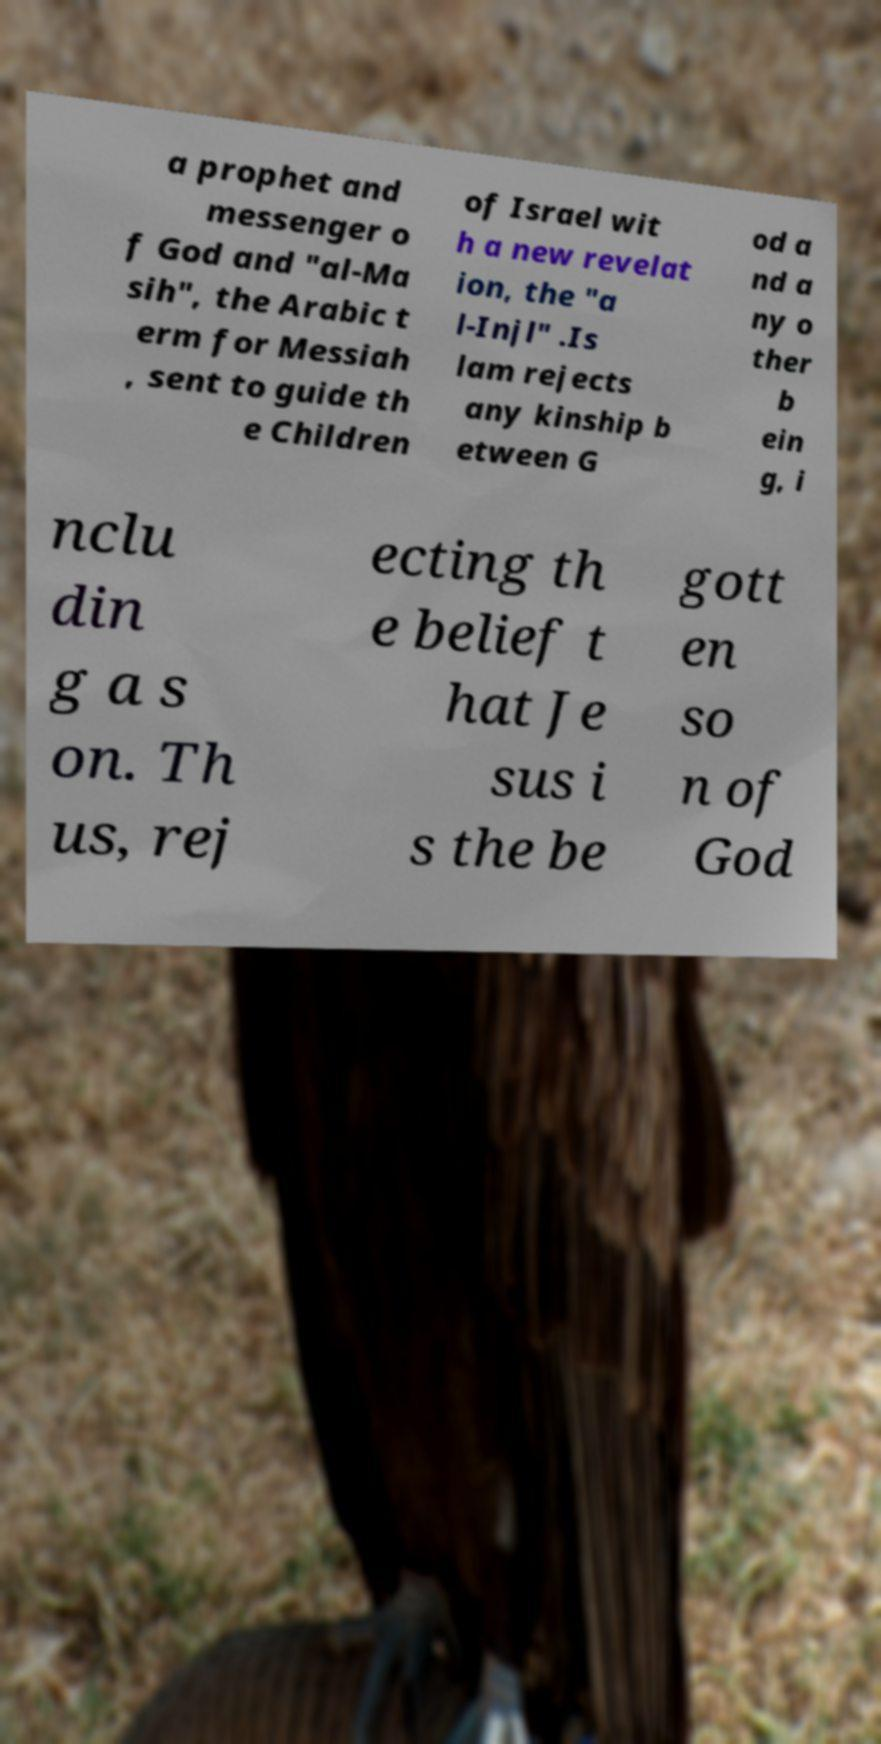Can you accurately transcribe the text from the provided image for me? a prophet and messenger o f God and "al-Ma sih", the Arabic t erm for Messiah , sent to guide th e Children of Israel wit h a new revelat ion, the "a l-Injl" .Is lam rejects any kinship b etween G od a nd a ny o ther b ein g, i nclu din g a s on. Th us, rej ecting th e belief t hat Je sus i s the be gott en so n of God 